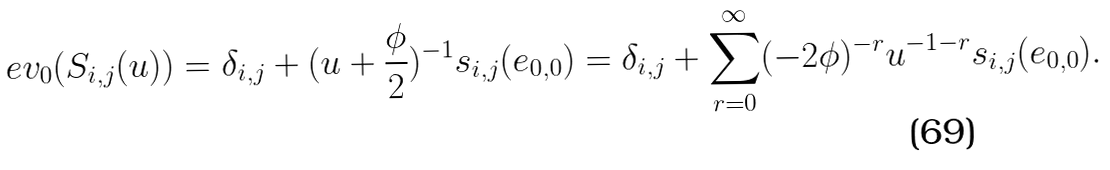<formula> <loc_0><loc_0><loc_500><loc_500>\ e v _ { 0 } ( S _ { i , j } ( u ) ) = \delta _ { i , j } + ( u + { \frac { \phi } { 2 } } ) ^ { - 1 } s _ { i , j } ( e _ { 0 , 0 } ) = \delta _ { i , j } + \sum _ { r = 0 } ^ { \infty } ( - 2 \phi ) ^ { - r } u ^ { - 1 - r } s _ { i , j } ( e _ { 0 , 0 } ) .</formula> 